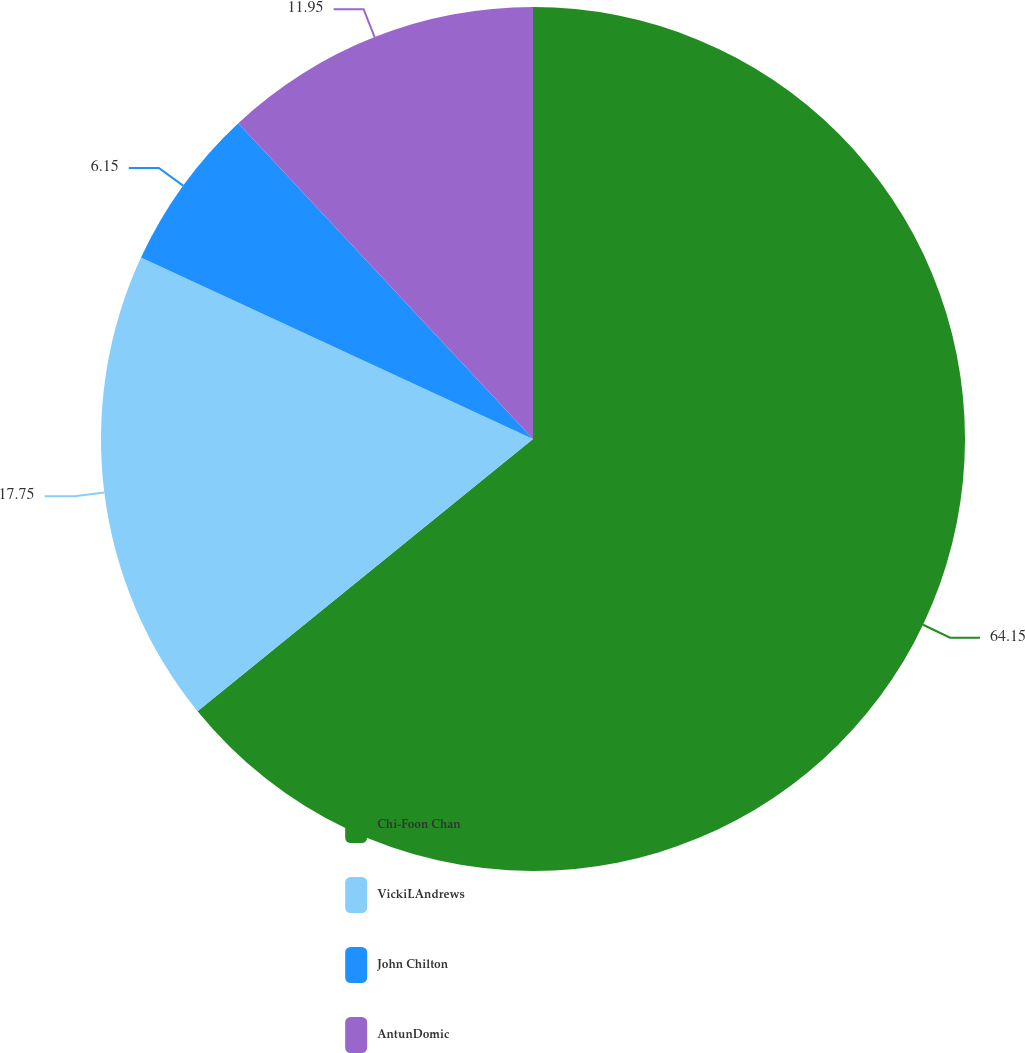<chart> <loc_0><loc_0><loc_500><loc_500><pie_chart><fcel>Chi-Foon Chan<fcel>VickiLAndrews<fcel>John Chilton<fcel>AntunDomic<nl><fcel>64.15%<fcel>17.75%<fcel>6.15%<fcel>11.95%<nl></chart> 